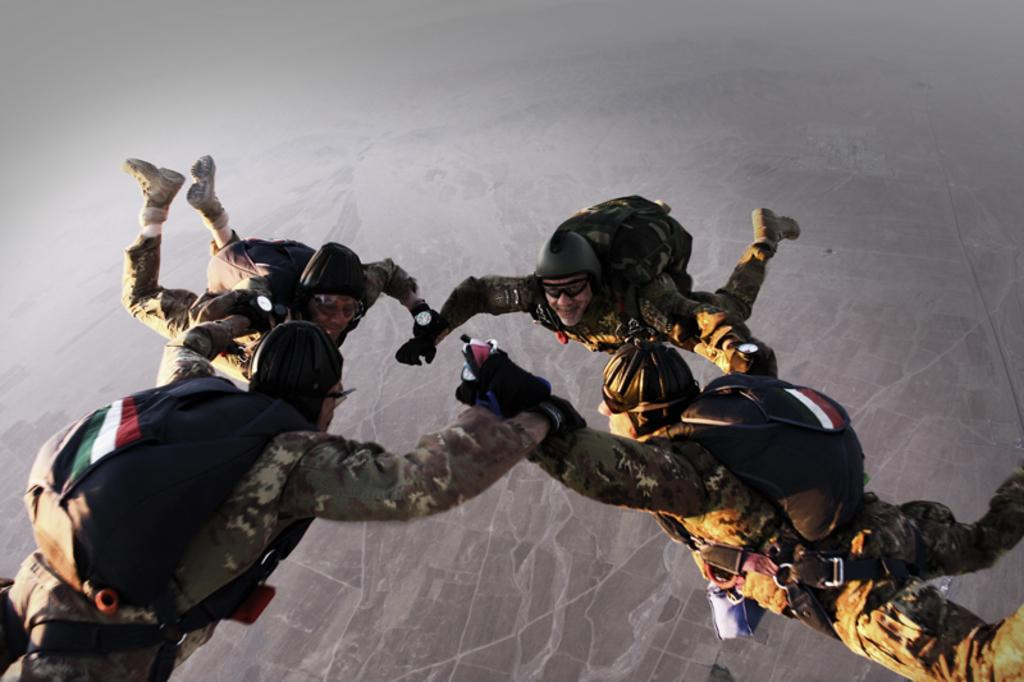What type of people can be seen in the image? There are men in the image. Where are the men located in the image? The men are in the air. What are the men wearing on their backs? The men are wearing backpacks. What type of yoke can be seen in the image? There is no yoke present in the image. How does the image relate to the concept of debt? The image does not directly relate to the concept of debt; it features men in the air wearing backpacks. 